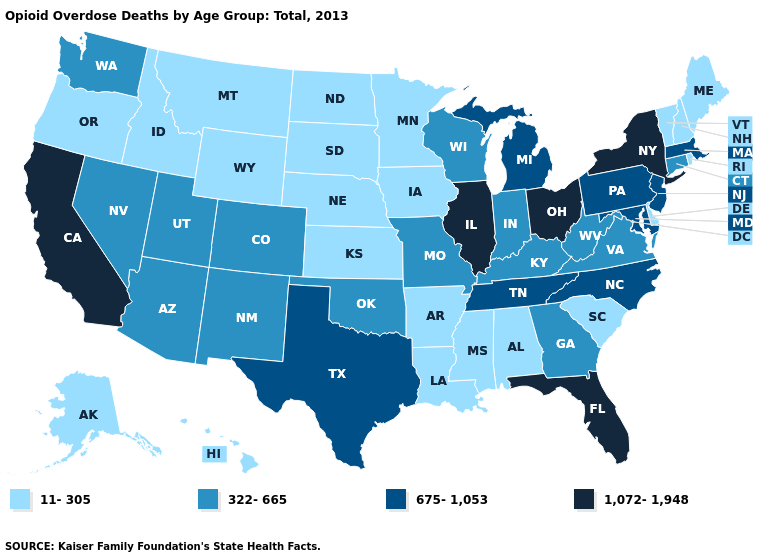Name the states that have a value in the range 1,072-1,948?
Concise answer only. California, Florida, Illinois, New York, Ohio. Does the first symbol in the legend represent the smallest category?
Be succinct. Yes. Does the map have missing data?
Be succinct. No. What is the highest value in states that border Michigan?
Give a very brief answer. 1,072-1,948. What is the value of Oregon?
Concise answer only. 11-305. Does the map have missing data?
Give a very brief answer. No. What is the value of Washington?
Write a very short answer. 322-665. Which states hav the highest value in the West?
Write a very short answer. California. Name the states that have a value in the range 322-665?
Be succinct. Arizona, Colorado, Connecticut, Georgia, Indiana, Kentucky, Missouri, Nevada, New Mexico, Oklahoma, Utah, Virginia, Washington, West Virginia, Wisconsin. Does Indiana have a lower value than New York?
Keep it brief. Yes. What is the value of Oklahoma?
Keep it brief. 322-665. What is the value of Hawaii?
Quick response, please. 11-305. Among the states that border New Hampshire , does Maine have the highest value?
Be succinct. No. What is the value of California?
Write a very short answer. 1,072-1,948. What is the value of Wyoming?
Concise answer only. 11-305. 